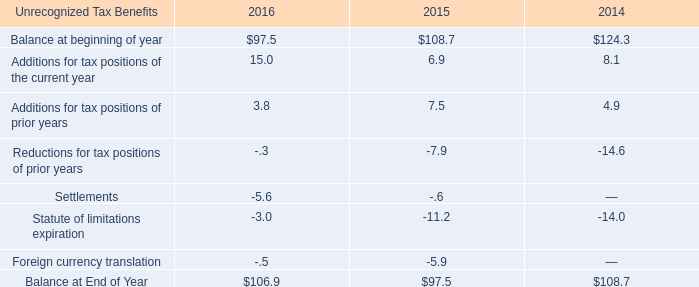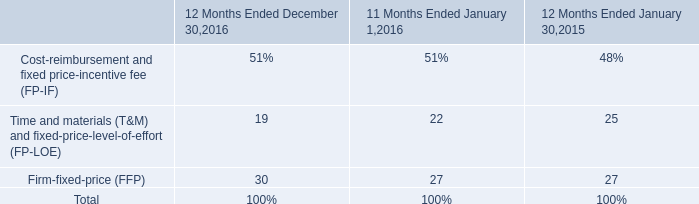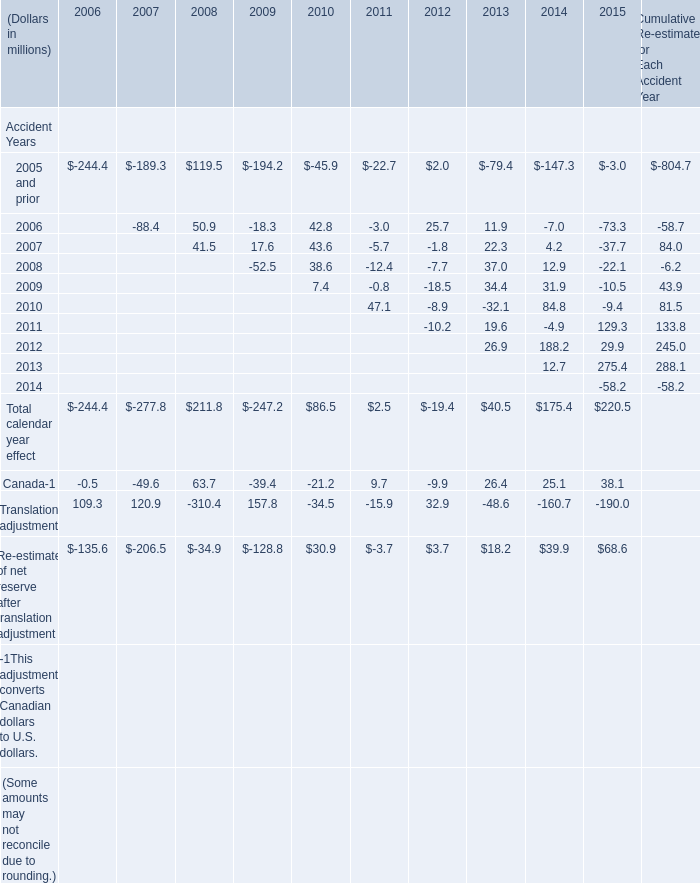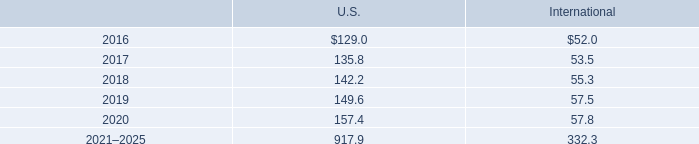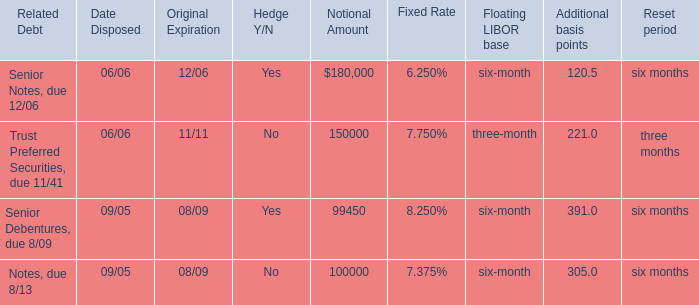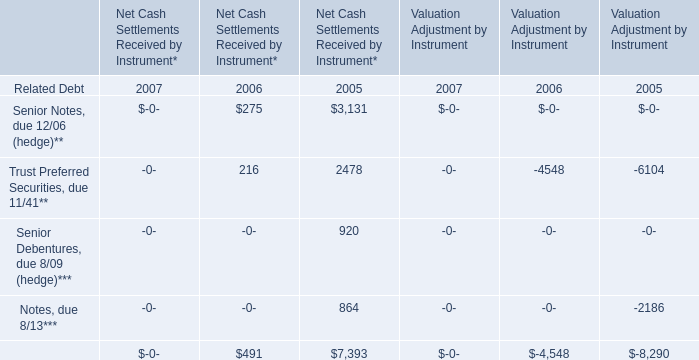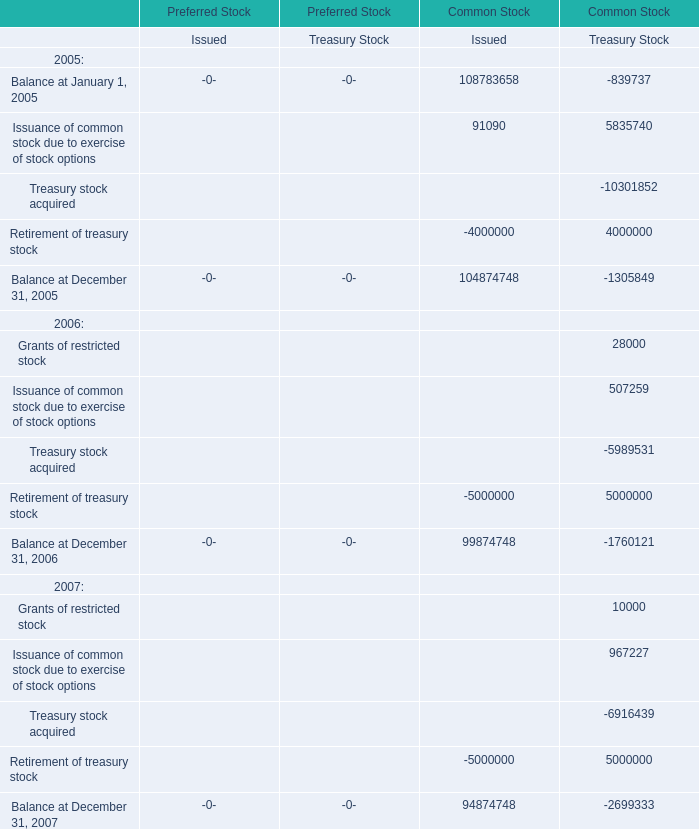In the year with lowest amount of Total calendar year effect，what's the increasing rate of Translation adjustment？ 
Computations: ((-310.4 - 120.9) / 120.9)
Answer: -3.56741. 